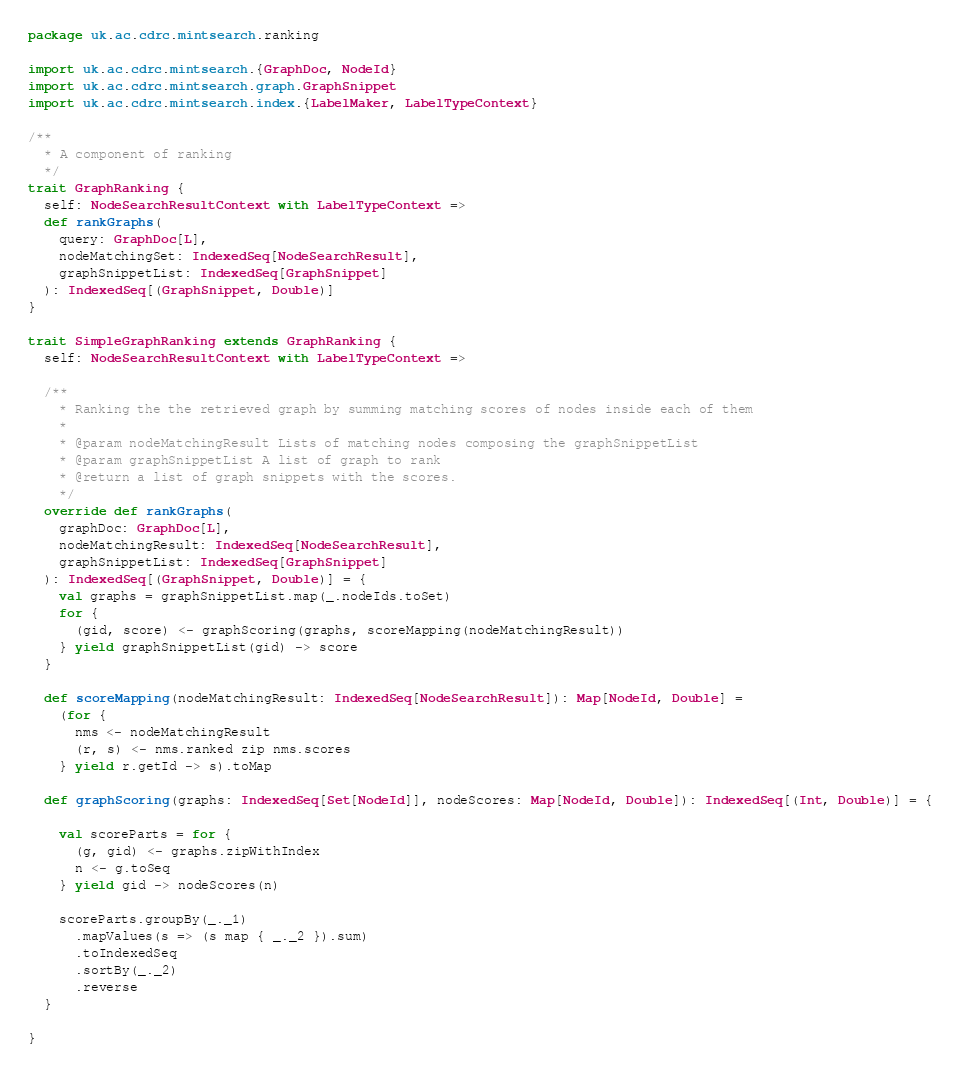Convert code to text. <code><loc_0><loc_0><loc_500><loc_500><_Scala_>package uk.ac.cdrc.mintsearch.ranking

import uk.ac.cdrc.mintsearch.{GraphDoc, NodeId}
import uk.ac.cdrc.mintsearch.graph.GraphSnippet
import uk.ac.cdrc.mintsearch.index.{LabelMaker, LabelTypeContext}

/**
  * A component of ranking
  */
trait GraphRanking {
  self: NodeSearchResultContext with LabelTypeContext =>
  def rankGraphs(
    query: GraphDoc[L],
    nodeMatchingSet: IndexedSeq[NodeSearchResult],
    graphSnippetList: IndexedSeq[GraphSnippet]
  ): IndexedSeq[(GraphSnippet, Double)]
}

trait SimpleGraphRanking extends GraphRanking {
  self: NodeSearchResultContext with LabelTypeContext =>

  /**
    * Ranking the the retrieved graph by summing matching scores of nodes inside each of them
    *
    * @param nodeMatchingResult Lists of matching nodes composing the graphSnippetList
    * @param graphSnippetList A list of graph to rank
    * @return a list of graph snippets with the scores.
    */
  override def rankGraphs(
    graphDoc: GraphDoc[L],
    nodeMatchingResult: IndexedSeq[NodeSearchResult],
    graphSnippetList: IndexedSeq[GraphSnippet]
  ): IndexedSeq[(GraphSnippet, Double)] = {
    val graphs = graphSnippetList.map(_.nodeIds.toSet)
    for {
      (gid, score) <- graphScoring(graphs, scoreMapping(nodeMatchingResult))
    } yield graphSnippetList(gid) -> score
  }

  def scoreMapping(nodeMatchingResult: IndexedSeq[NodeSearchResult]): Map[NodeId, Double] =
    (for {
      nms <- nodeMatchingResult
      (r, s) <- nms.ranked zip nms.scores
    } yield r.getId -> s).toMap

  def graphScoring(graphs: IndexedSeq[Set[NodeId]], nodeScores: Map[NodeId, Double]): IndexedSeq[(Int, Double)] = {

    val scoreParts = for {
      (g, gid) <- graphs.zipWithIndex
      n <- g.toSeq
    } yield gid -> nodeScores(n)

    scoreParts.groupBy(_._1)
      .mapValues(s => (s map { _._2 }).sum)
      .toIndexedSeq
      .sortBy(_._2)
      .reverse
  }

}
</code> 